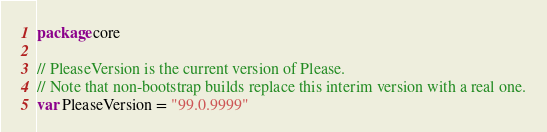Convert code to text. <code><loc_0><loc_0><loc_500><loc_500><_Go_>package core

// PleaseVersion is the current version of Please.
// Note that non-bootstrap builds replace this interim version with a real one.
var PleaseVersion = "99.0.9999"
</code> 